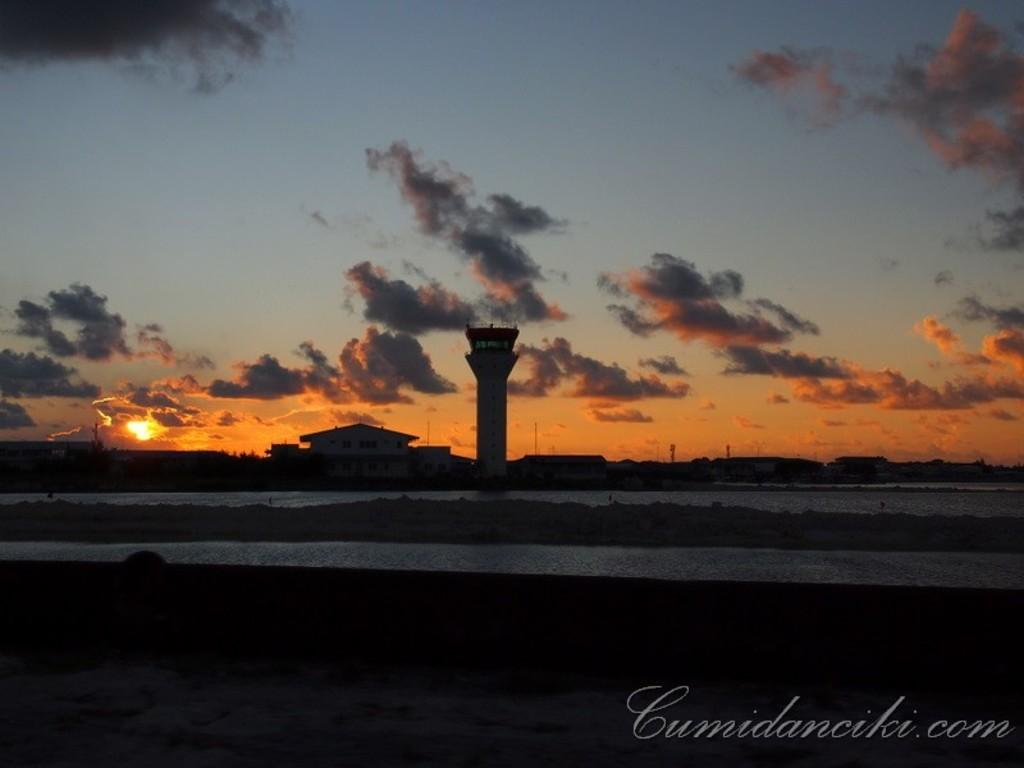How many lakes can be seen in the image? There are two lakes separated by dry land in the image. What is located in front of the lakes? There is a watermark in front of the lakes. What can be seen in the background of the image? There is a tower, buildings, trees, the sun, and clouds visible in the background. What type of cake is being served at the lakeside in the image? There is no cake present in the image. 